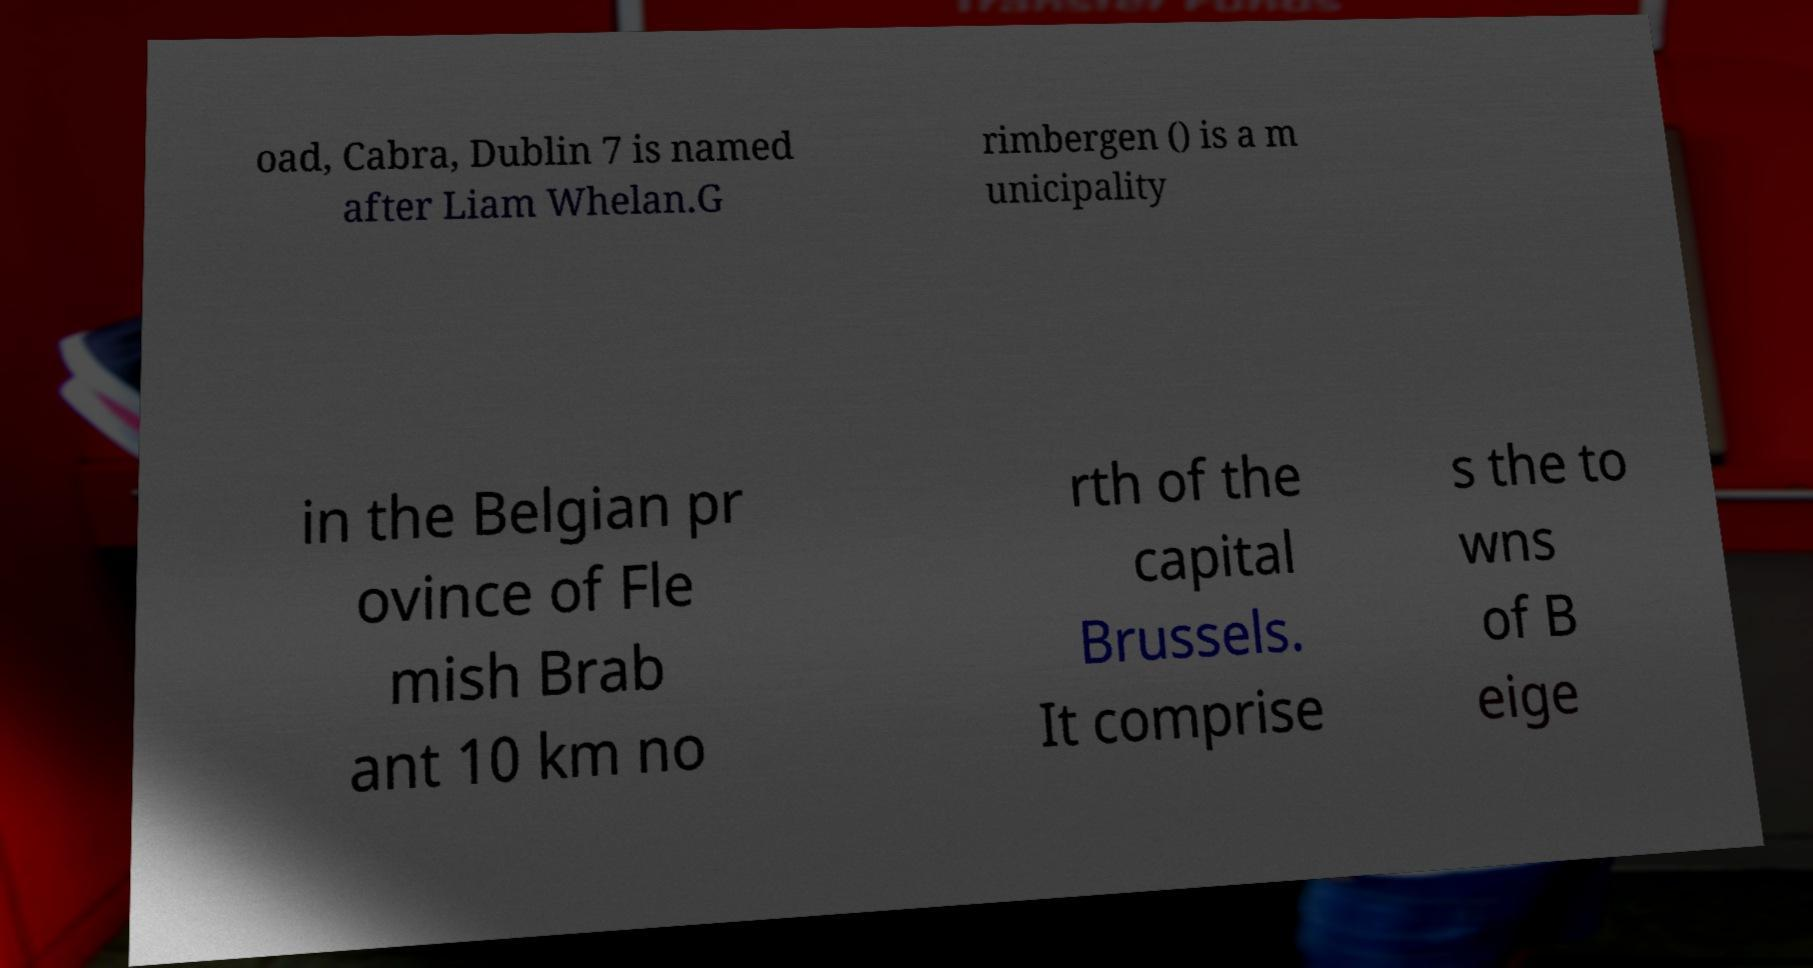What messages or text are displayed in this image? I need them in a readable, typed format. oad, Cabra, Dublin 7 is named after Liam Whelan.G rimbergen () is a m unicipality in the Belgian pr ovince of Fle mish Brab ant 10 km no rth of the capital Brussels. It comprise s the to wns of B eige 